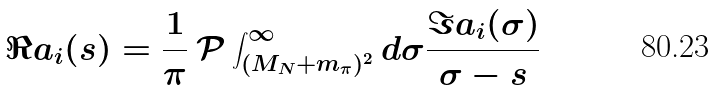Convert formula to latex. <formula><loc_0><loc_0><loc_500><loc_500>\Re a _ { i } ( s ) = \frac { 1 } { \pi } \, \mathcal { P } \int _ { ( M _ { N } + m _ { \pi } ) ^ { 2 } } ^ { \infty } d \sigma \frac { \Im a _ { i } ( \sigma ) } { \sigma - s }</formula> 